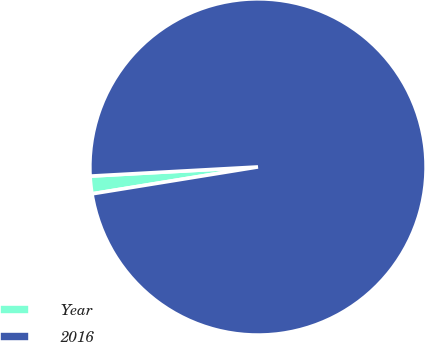<chart> <loc_0><loc_0><loc_500><loc_500><pie_chart><fcel>Year<fcel>2016<nl><fcel>1.69%<fcel>98.31%<nl></chart> 